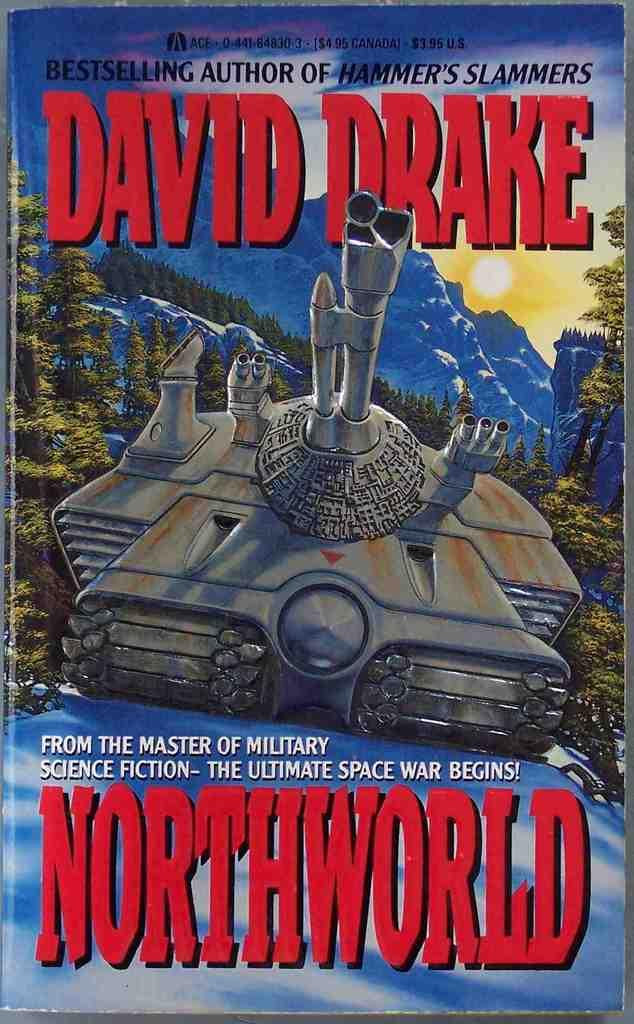What is present on the poster in the image? There is a poster in the image. What can be seen on the poster besides text? The poster contains images. What type of information is present on the poster? There is text on the poster. What type of meal is being served on the poster? There is no meal present on the poster; it contains images and text. What kind of advice is being given on the poster? There is no advice present on the poster; it contains images and text. 